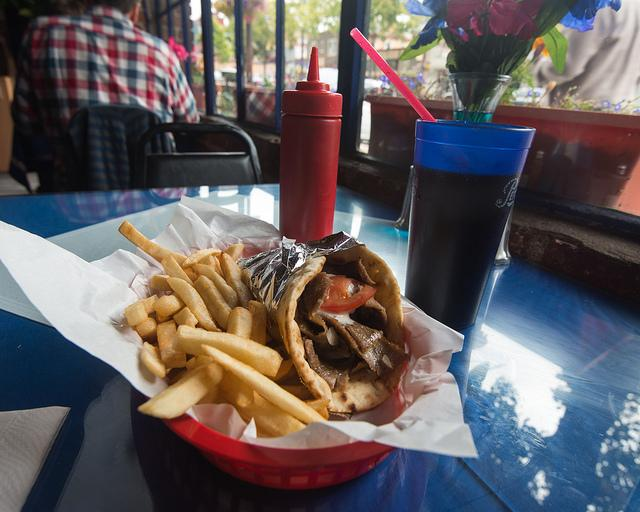What type of food is in the tinfoil?

Choices:
A) pita
B) tortilla
C) laffa
D) pie laffa 